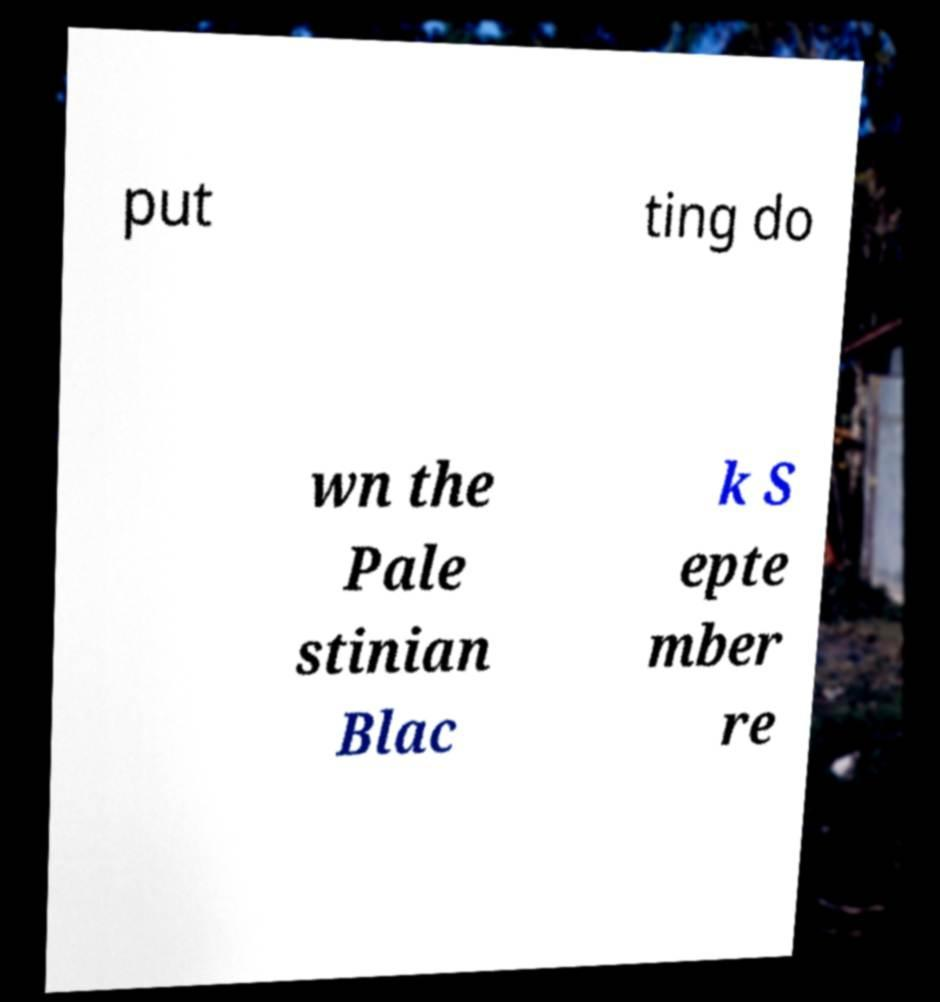Could you extract and type out the text from this image? put ting do wn the Pale stinian Blac k S epte mber re 